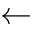<formula> <loc_0><loc_0><loc_500><loc_500>\leftarrow</formula> 